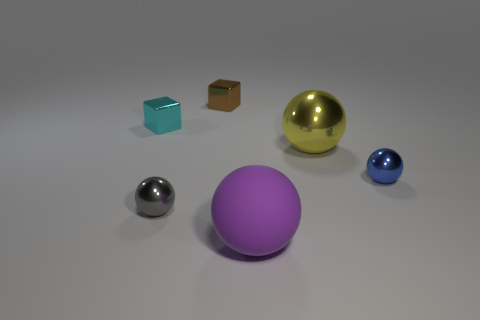Can you describe the different materials the objects appear to be made of? Yes, the objects seem to have a variety of textures and finishes. The largest spherical object appears to have a smooth, matte finish and is likely a soft material like rubber, given its purple color. The golden sphere next to it has a shiny, reflective surface, suggesting a polished metal, possibly gold. The small blue sphere has a similar reflective quality, though it's likely glass or a polished semi-precious stone. The smaller objects to the left seem to be made of different materials as well; the smallest one looks metallic, possibly steel, while the blue cube appears to be translucent, maybe a type of plastic or glass. The brown cube has a matte finish that could either be wood or a composite. 